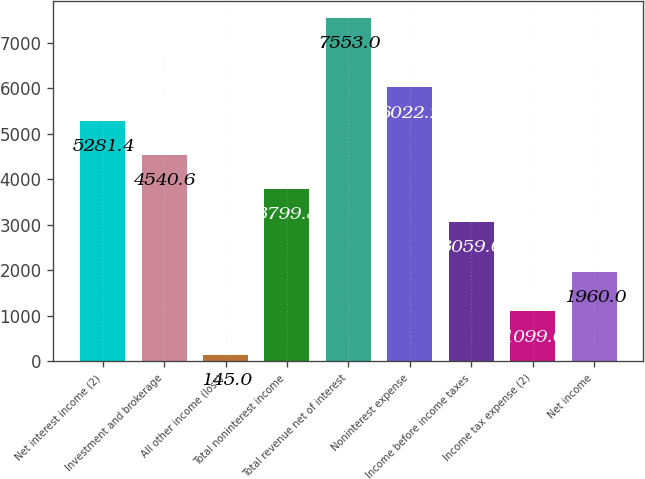Convert chart to OTSL. <chart><loc_0><loc_0><loc_500><loc_500><bar_chart><fcel>Net interest income (2)<fcel>Investment and brokerage<fcel>All other income (loss)<fcel>Total noninterest income<fcel>Total revenue net of interest<fcel>Noninterest expense<fcel>Income before income taxes<fcel>Income tax expense (2)<fcel>Net income<nl><fcel>5281.4<fcel>4540.6<fcel>145<fcel>3799.8<fcel>7553<fcel>6022.2<fcel>3059<fcel>1099<fcel>1960<nl></chart> 